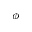Convert formula to latex. <formula><loc_0><loc_0><loc_500><loc_500>\phi</formula> 